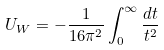Convert formula to latex. <formula><loc_0><loc_0><loc_500><loc_500>U _ { W } = - \frac { 1 } { 1 6 \pi ^ { 2 } } \int _ { 0 } ^ { \infty } \frac { d t } { t ^ { 2 } }</formula> 